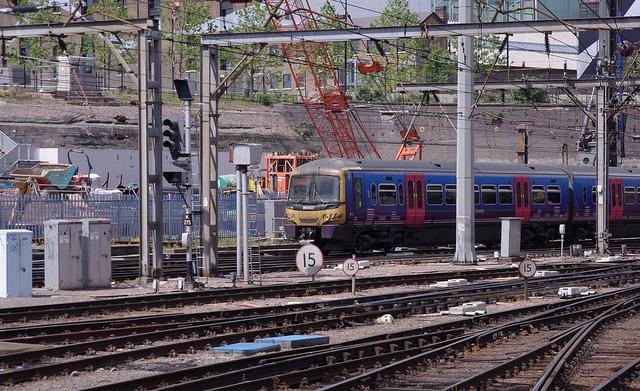Where is the train going?
Keep it brief. Left. Is this train moving?
Be succinct. Yes. What is the color on the front of the train?
Answer briefly. Yellow. 